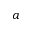Convert formula to latex. <formula><loc_0><loc_0><loc_500><loc_500>a</formula> 